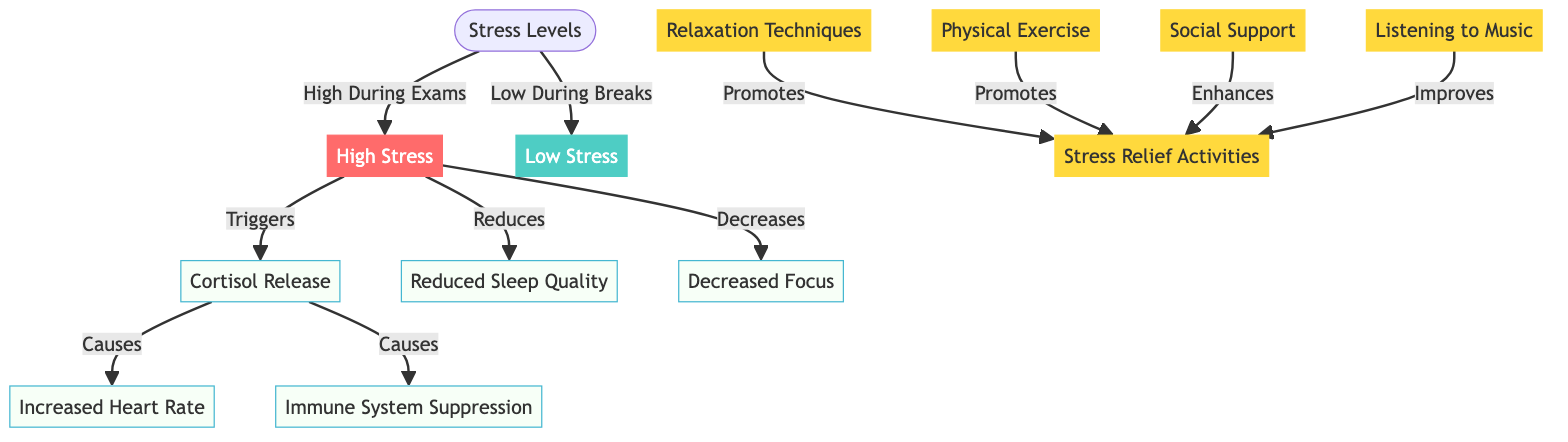What are the stress levels during exam periods? The diagram indicates that the stress levels are categorized as "High During Exams" for high stress and "Low During Breaks" for low stress. Therefore, the stress levels during exam periods are specifically high.
Answer: High How many impacts are linked to high stress? The diagram shows that high stress leads to five outcomes: cortisol release, increased heart rate, immune system suppression, reduced sleep quality, and decreased focus. Counting these nodes gives a total of five impacts linked to high stress.
Answer: 5 What activity promotes stress relief according to the diagram? The diagram lists several activities that promote stress relief, including relaxation techniques, physical exercise, social support, and listening to music. Thus, any of these activities serves as an answer.
Answer: Relaxation Techniques What is the relationship between cortisol and increased heart rate? The diagram indicates that "Cortisol Release" triggers "Increased Heart Rate." This shows that cortisol release leads to an increase in heart rate as part of its physiological impact.
Answer: Triggers What type of stress is associated with reduced sleep quality? The diagram clearly shows that reduced sleep quality is a consequence of "High Stress." Therefore, the type of stress associated with this outcome is categorized as high stress.
Answer: High Stress What does social support enhance according to the diagram? The diagram states that "Social Support" enhances "Stress Relief Activities." This means that having social support plays a positive role in alleviating stress through various activities.
Answer: Stress Relief Activities How does high stress affect the immune system? The diagram reveals that high stress triggers cortisol release, which subsequently causes immune system suppression. This means that high stress negatively impacts the immune system.
Answer: Causes Immune System Suppression Which element in the diagram is specifically aimed to improve stress relief? The diagram mentions "Listening to Music" as one of the activities that improves stress relief. This indicates that engaging with music is a constructive way to alleviate stress.
Answer: Listening to Music What are the physiological impacts shown in the diagram? The diagram outlines multiple physiological impacts, including cortisol release, increased heart rate, immune system suppression, reduced sleep quality, and decreased focus. These elements summarize the various physiological impacts.
Answer: Cortisol Release, Increased Heart Rate, Immune System Suppression, Reduced Sleep Quality, Decreased Focus 